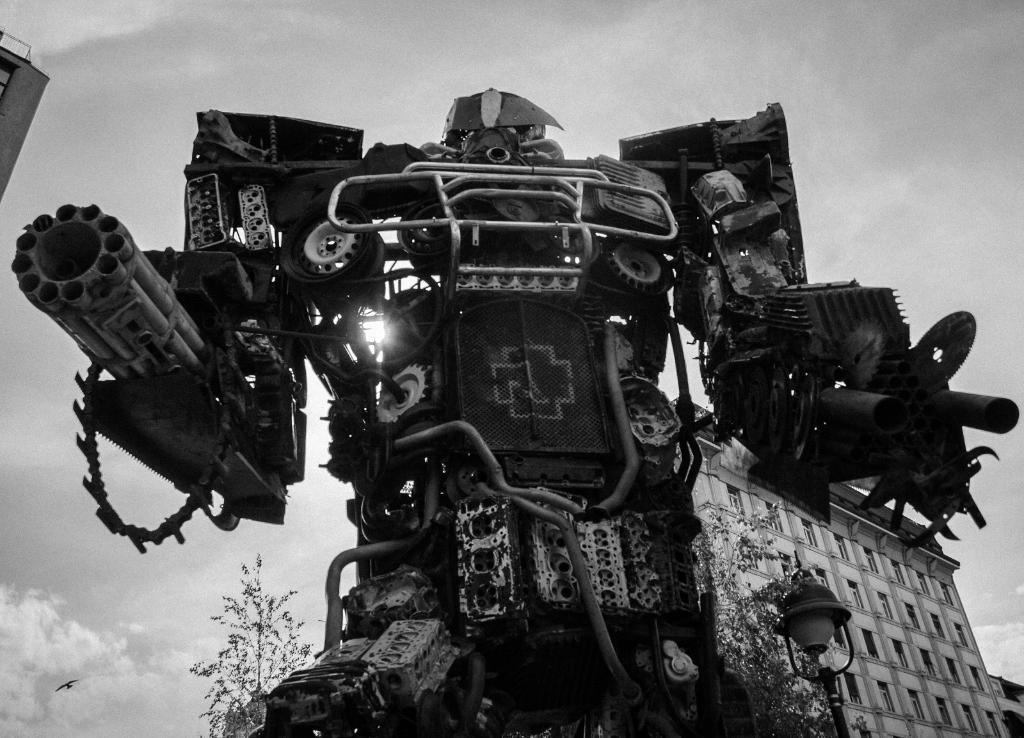In one or two sentences, can you explain what this image depicts? This is a black and white. In this image, in the middle, we can see a metal instrument. On the right side, we can see some buildings, trees, street light. On the left side, we can see a bird which is in the air. On the left side top, we can see a wall of the building. At the top, we can see a sky which is cloudy. 